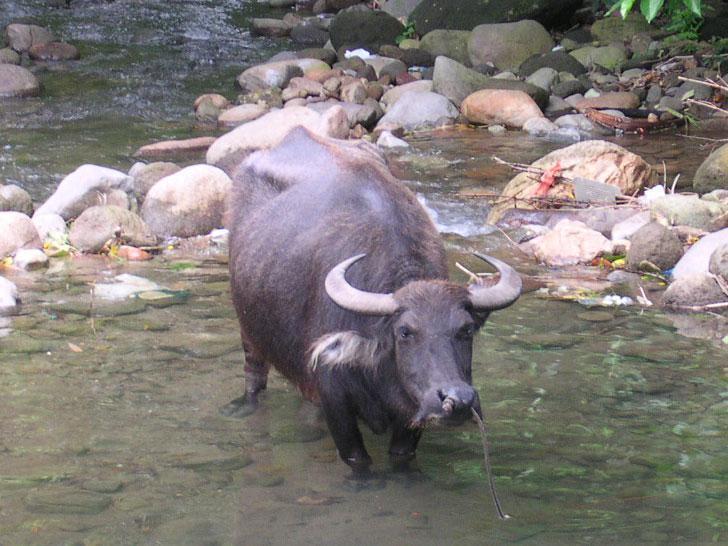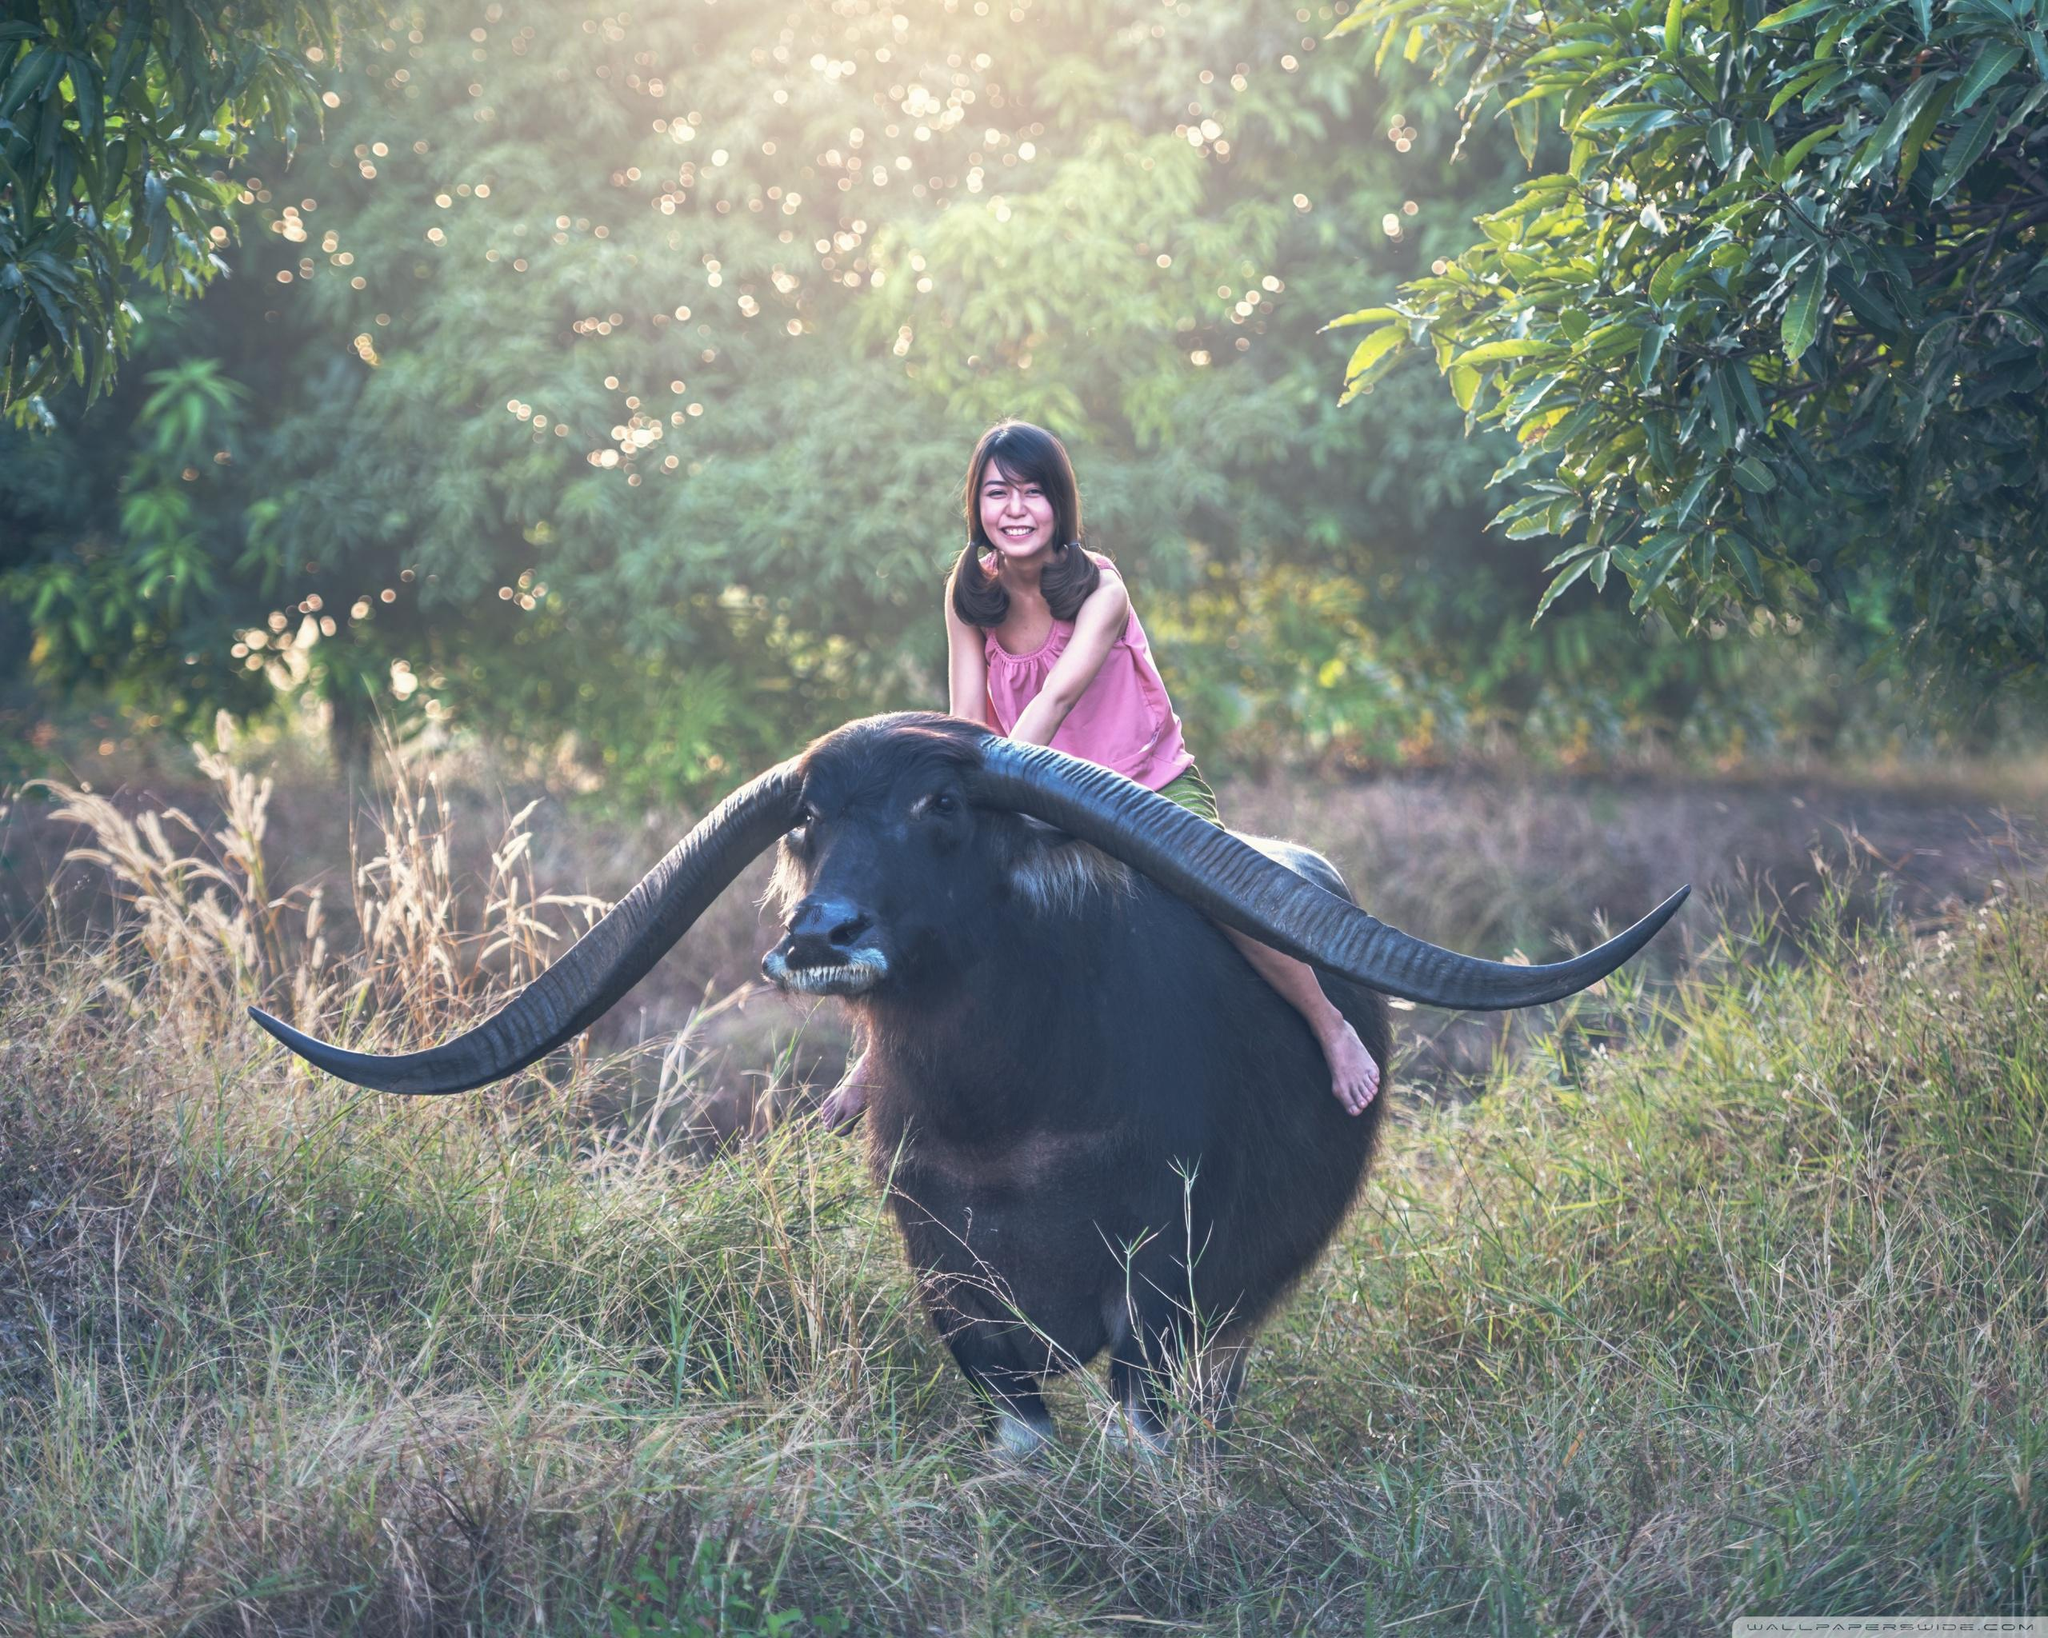The first image is the image on the left, the second image is the image on the right. Considering the images on both sides, is "The right image contains at least two people riding on a water buffalo." valid? Answer yes or no. No. The first image is the image on the left, the second image is the image on the right. Assess this claim about the two images: "At least one water buffalo is standing in water in the left image.". Correct or not? Answer yes or no. Yes. 